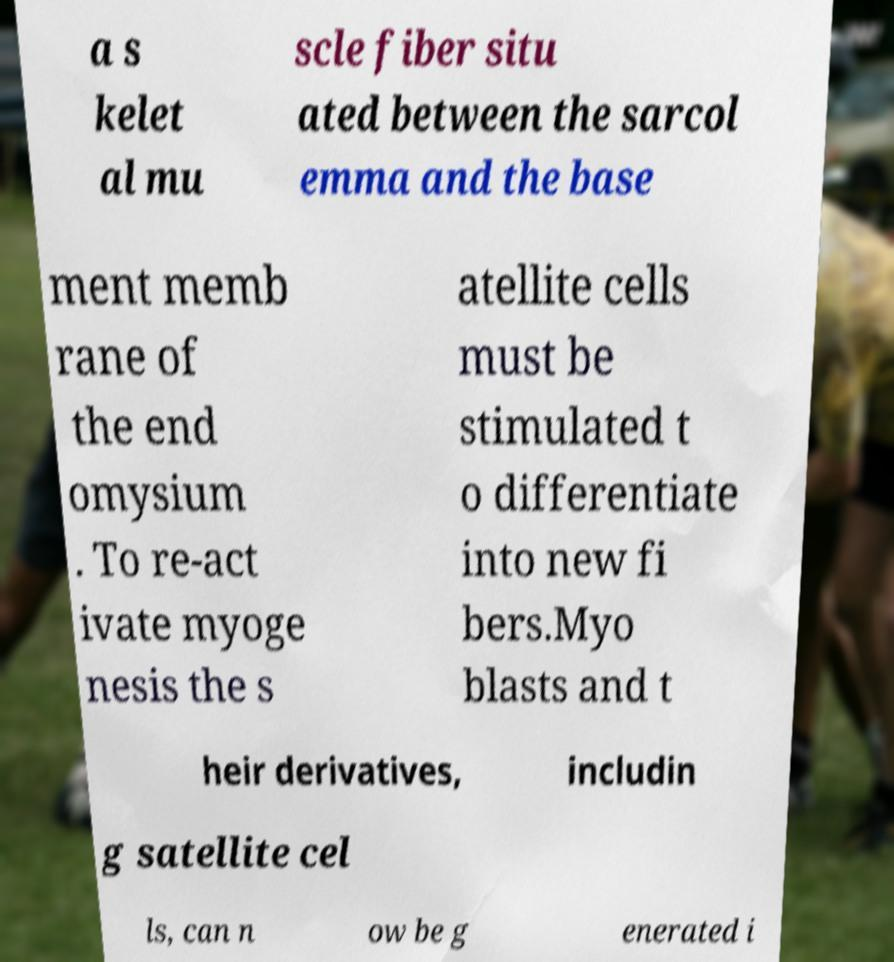Could you extract and type out the text from this image? a s kelet al mu scle fiber situ ated between the sarcol emma and the base ment memb rane of the end omysium . To re-act ivate myoge nesis the s atellite cells must be stimulated t o differentiate into new fi bers.Myo blasts and t heir derivatives, includin g satellite cel ls, can n ow be g enerated i 